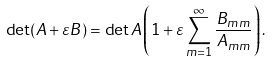<formula> <loc_0><loc_0><loc_500><loc_500>\det ( { A } + \varepsilon { B } ) = \det { A } \left ( 1 + \varepsilon \sum _ { m = 1 } ^ { \infty } \frac { B _ { m m } } { A _ { m m } } \right ) .</formula> 